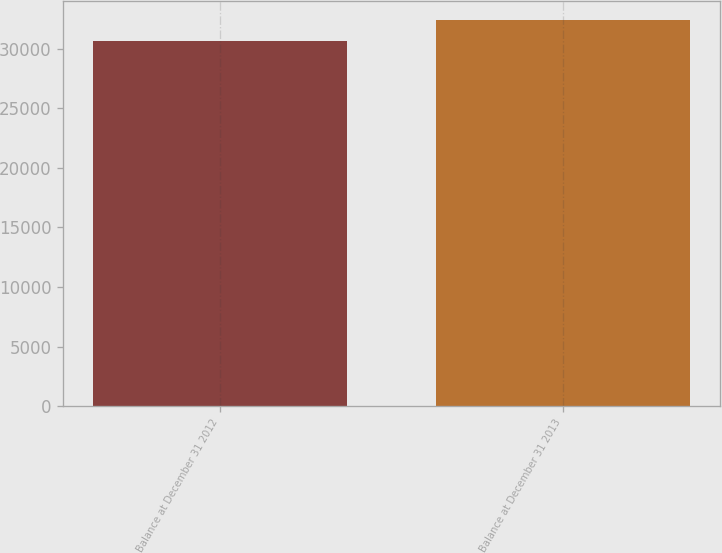<chart> <loc_0><loc_0><loc_500><loc_500><bar_chart><fcel>Balance at December 31 2012<fcel>Balance at December 31 2013<nl><fcel>30679<fcel>32416<nl></chart> 